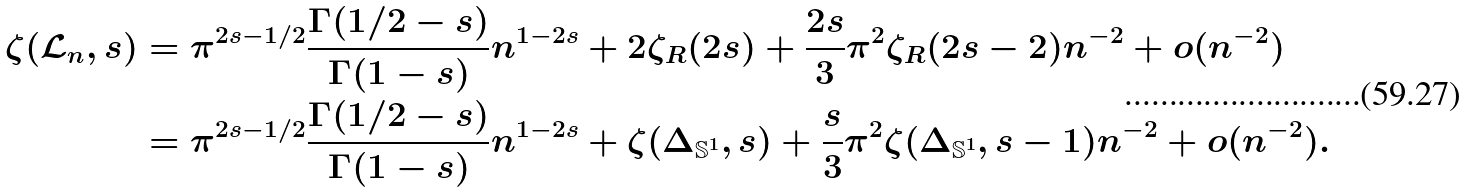Convert formula to latex. <formula><loc_0><loc_0><loc_500><loc_500>\zeta ( \mathcal { L } _ { n } , s ) & = \pi ^ { 2 s - 1 / 2 } \frac { \Gamma ( 1 / 2 - s ) } { \Gamma ( 1 - s ) } n ^ { 1 - 2 s } + 2 \zeta _ { R } ( 2 s ) + \frac { 2 s } { 3 } \pi ^ { 2 } \zeta _ { R } ( 2 s - 2 ) n ^ { - 2 } + o ( n ^ { - 2 } ) \\ & = \pi ^ { 2 s - 1 / 2 } \frac { \Gamma ( 1 / 2 - s ) } { \Gamma ( 1 - s ) } n ^ { 1 - 2 s } + \zeta ( \Delta _ { \mathbb { S } ^ { 1 } } , s ) + \frac { s } { 3 } \pi ^ { 2 } \zeta ( \Delta _ { \mathbb { S } ^ { 1 } } , s - 1 ) n ^ { - 2 } + o ( n ^ { - 2 } ) .</formula> 